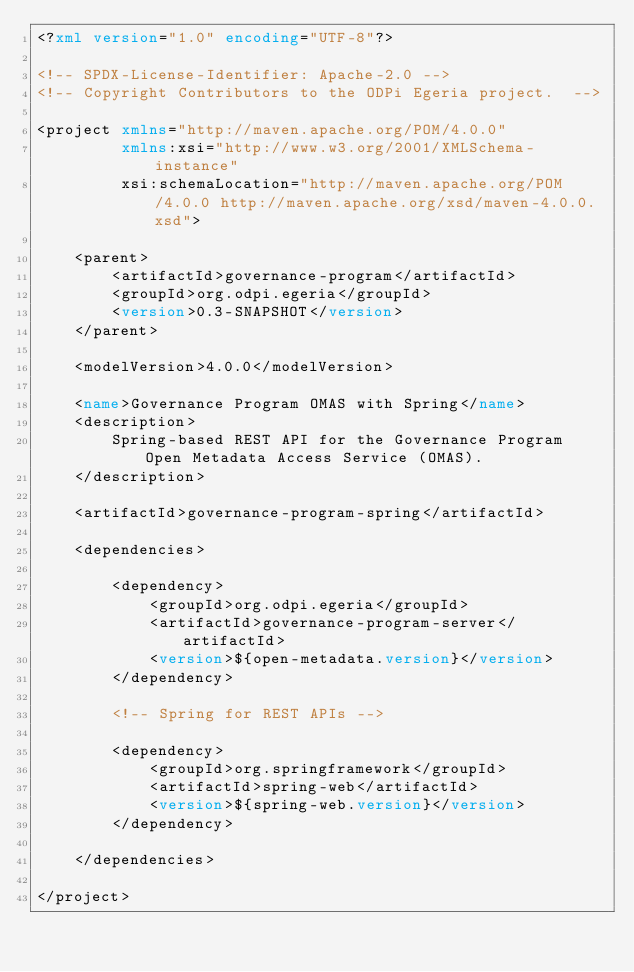Convert code to text. <code><loc_0><loc_0><loc_500><loc_500><_XML_><?xml version="1.0" encoding="UTF-8"?>

<!-- SPDX-License-Identifier: Apache-2.0 -->
<!-- Copyright Contributors to the ODPi Egeria project.  -->

<project xmlns="http://maven.apache.org/POM/4.0.0"
         xmlns:xsi="http://www.w3.org/2001/XMLSchema-instance"
         xsi:schemaLocation="http://maven.apache.org/POM/4.0.0 http://maven.apache.org/xsd/maven-4.0.0.xsd">

    <parent>
        <artifactId>governance-program</artifactId>
        <groupId>org.odpi.egeria</groupId>
        <version>0.3-SNAPSHOT</version>
    </parent>

    <modelVersion>4.0.0</modelVersion>

    <name>Governance Program OMAS with Spring</name>
    <description>
        Spring-based REST API for the Governance Program Open Metadata Access Service (OMAS).
    </description>

    <artifactId>governance-program-spring</artifactId>

    <dependencies>

        <dependency>
            <groupId>org.odpi.egeria</groupId>
            <artifactId>governance-program-server</artifactId>
            <version>${open-metadata.version}</version>
        </dependency>

        <!-- Spring for REST APIs -->

        <dependency>
            <groupId>org.springframework</groupId>
            <artifactId>spring-web</artifactId>
            <version>${spring-web.version}</version>
        </dependency>

    </dependencies>

</project></code> 